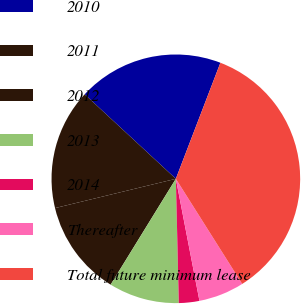Convert chart. <chart><loc_0><loc_0><loc_500><loc_500><pie_chart><fcel>2010<fcel>2011<fcel>2012<fcel>2013<fcel>2014<fcel>Thereafter<fcel>Total future minimum lease<nl><fcel>18.94%<fcel>15.68%<fcel>12.43%<fcel>9.17%<fcel>2.66%<fcel>5.92%<fcel>35.21%<nl></chart> 